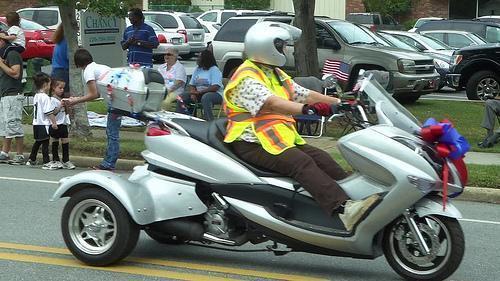How many people are on the bike?
Give a very brief answer. 1. 